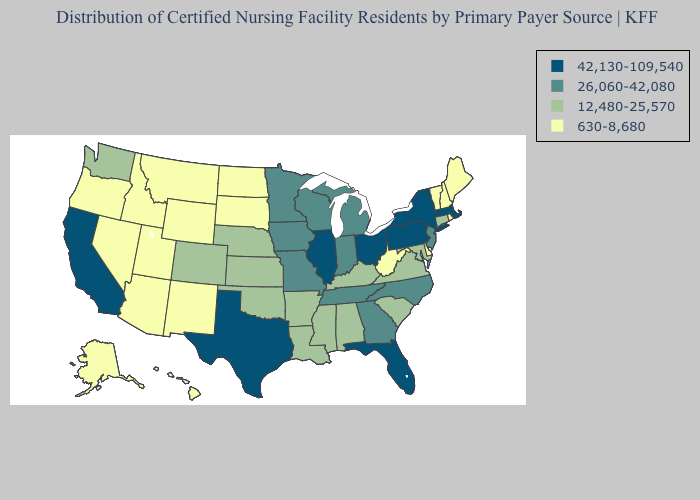Name the states that have a value in the range 42,130-109,540?
Write a very short answer. California, Florida, Illinois, Massachusetts, New York, Ohio, Pennsylvania, Texas. What is the highest value in the West ?
Give a very brief answer. 42,130-109,540. Among the states that border Arizona , which have the lowest value?
Answer briefly. Nevada, New Mexico, Utah. What is the highest value in the MidWest ?
Write a very short answer. 42,130-109,540. Name the states that have a value in the range 26,060-42,080?
Quick response, please. Georgia, Indiana, Iowa, Michigan, Minnesota, Missouri, New Jersey, North Carolina, Tennessee, Wisconsin. What is the value of Utah?
Be succinct. 630-8,680. Name the states that have a value in the range 26,060-42,080?
Keep it brief. Georgia, Indiana, Iowa, Michigan, Minnesota, Missouri, New Jersey, North Carolina, Tennessee, Wisconsin. Does Iowa have the lowest value in the USA?
Answer briefly. No. What is the value of Utah?
Quick response, please. 630-8,680. Name the states that have a value in the range 12,480-25,570?
Short answer required. Alabama, Arkansas, Colorado, Connecticut, Kansas, Kentucky, Louisiana, Maryland, Mississippi, Nebraska, Oklahoma, South Carolina, Virginia, Washington. What is the value of Iowa?
Quick response, please. 26,060-42,080. Does Wyoming have a lower value than North Dakota?
Keep it brief. No. Which states have the lowest value in the South?
Short answer required. Delaware, West Virginia. What is the lowest value in the South?
Answer briefly. 630-8,680. What is the value of Maryland?
Concise answer only. 12,480-25,570. 